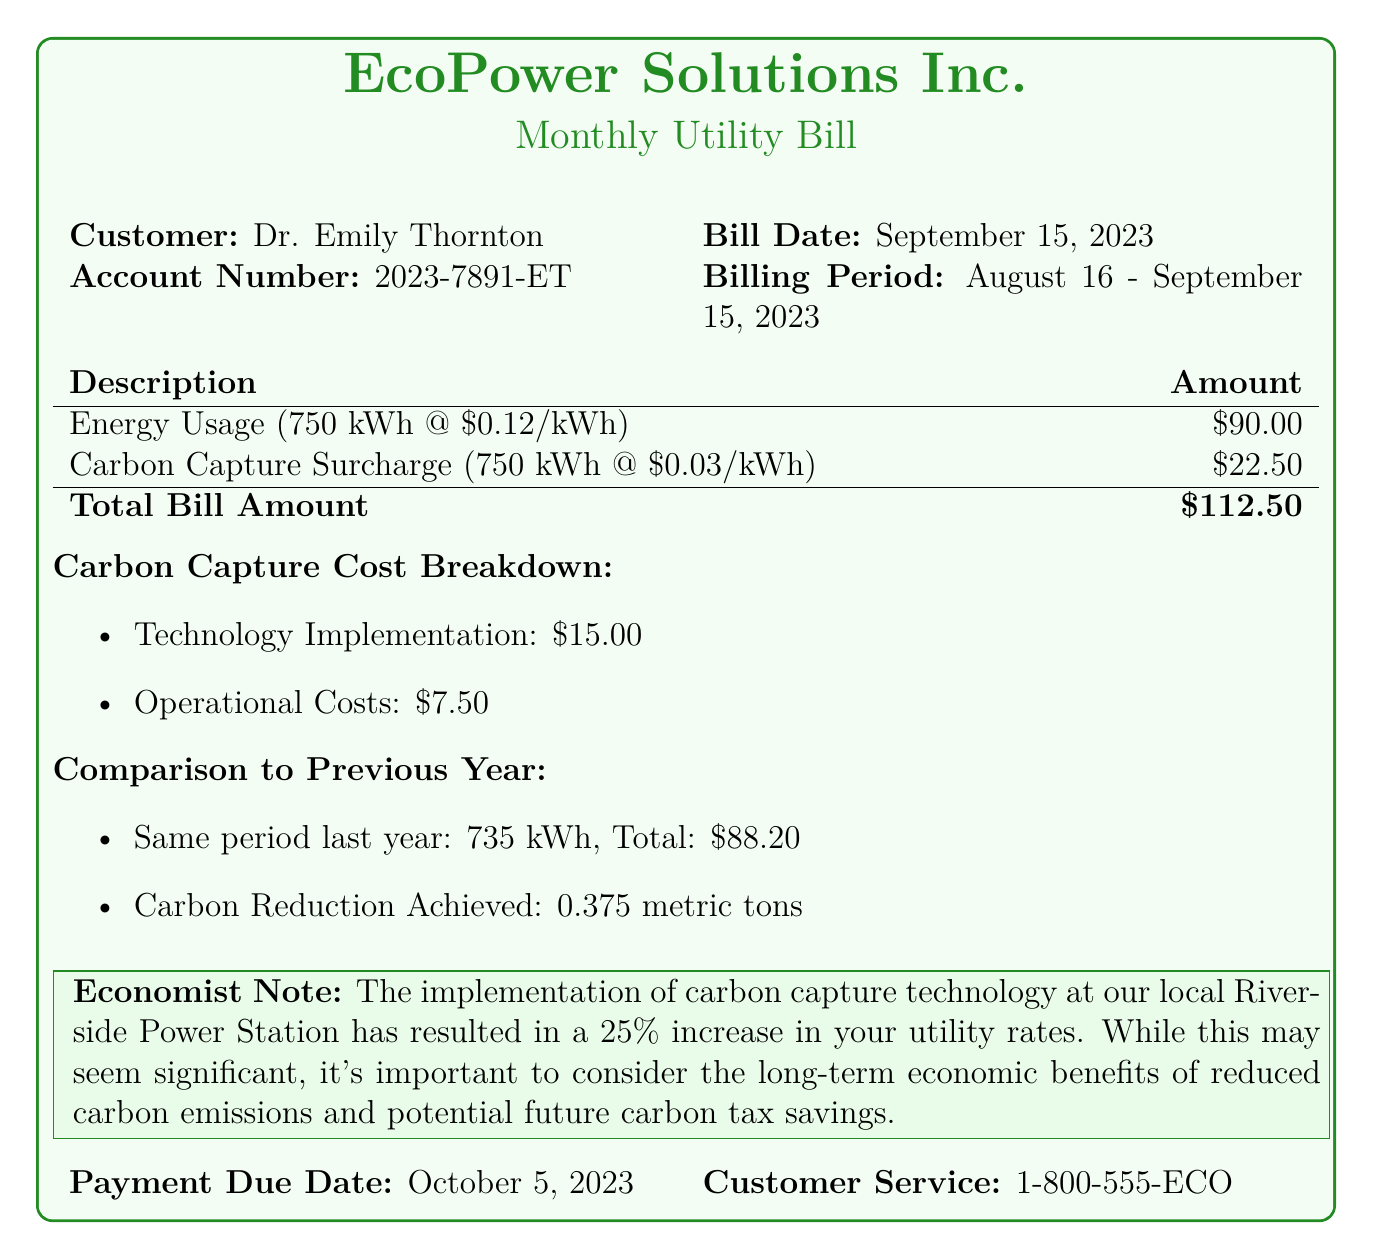What is the customer name? The customer's name is provided in the document under "Customer," which states Dr. Emily Thornton.
Answer: Dr. Emily Thornton What is the billing date? The billing date is specified in the document, listed as September 15, 2023.
Answer: September 15, 2023 What is the carbon capture surcharge per kWh? The document indicates the carbon capture surcharge is \$0.03 per kWh.
Answer: \$0.03 What is the total bill amount? The total bill amount is clearly stated in the bill, which sums the energy usage and carbon capture surcharge.
Answer: \$112.50 What was the energy usage this billing period? The energy usage is specified in the document as 750 kWh for this billing period.
Answer: 750 kWh How much more was paid this year compared to last year? The previous year’s total was \$88.20, and the current total is \$112.50, leading to a \$24.30 increase.
Answer: \$24.30 What is the payment due date? The payment due date is outlined in the document, marked as October 5, 2023.
Answer: October 5, 2023 What is one of the carbon capture technology costs? The document breaks down the carbon capture costs, with "Technology Implementation" costing \$15.00.
Answer: \$15.00 How much carbon reduction was achieved? The document mentions that the carbon reduction achieved for the same period last year was 0.375 metric tons.
Answer: 0.375 metric tons 